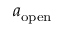Convert formula to latex. <formula><loc_0><loc_0><loc_500><loc_500>a _ { o p e n }</formula> 